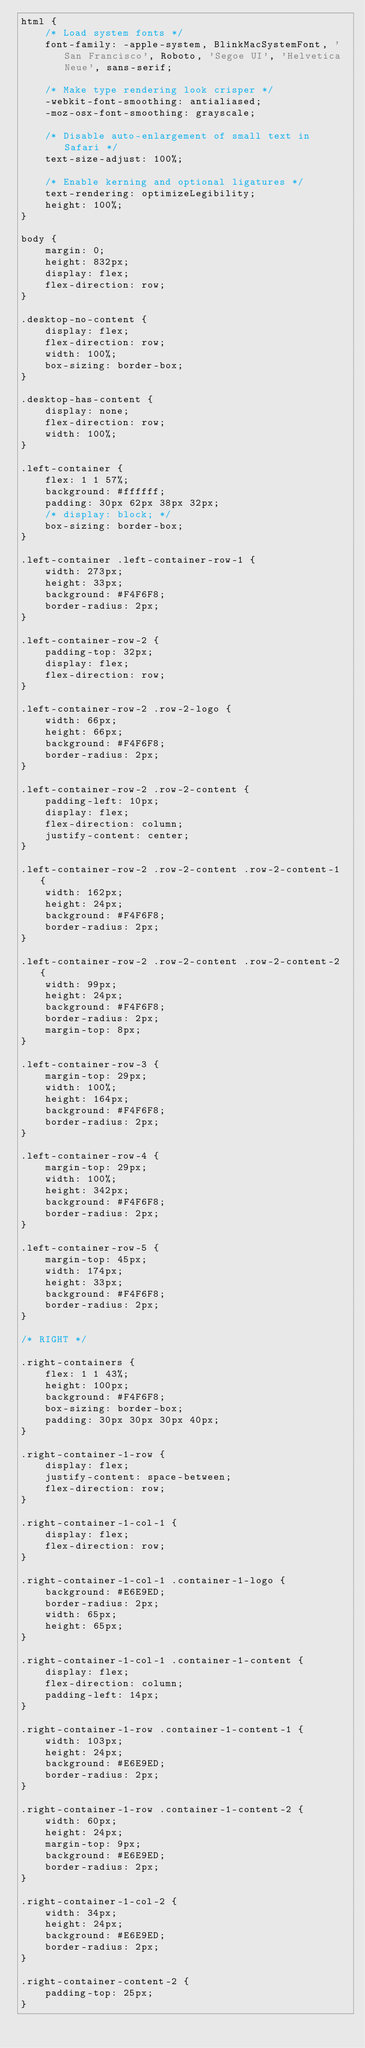Convert code to text. <code><loc_0><loc_0><loc_500><loc_500><_CSS_>html {
    /* Load system fonts */
    font-family: -apple-system, BlinkMacSystemFont, 'San Francisco', Roboto, 'Segoe UI', 'Helvetica Neue', sans-serif;
  
    /* Make type rendering look crisper */
    -webkit-font-smoothing: antialiased;
    -moz-osx-font-smoothing: grayscale;
  
    /* Disable auto-enlargement of small text in Safari */
    text-size-adjust: 100%;
  
    /* Enable kerning and optional ligatures */
    text-rendering: optimizeLegibility;
    height: 100%;
}

body {
    margin: 0;
    height: 832px;
    display: flex;
    flex-direction: row;
}

.desktop-no-content {
    display: flex;
    flex-direction: row;
    width: 100%;
    box-sizing: border-box;
}

.desktop-has-content {
    display: none;
    flex-direction: row;
    width: 100%;
}

.left-container {
    flex: 1 1 57%;
    background: #ffffff;
    padding: 30px 62px 38px 32px;
    /* display: block; */
    box-sizing: border-box;
}

.left-container .left-container-row-1 {
    width: 273px;
    height: 33px;
    background: #F4F6F8;
    border-radius: 2px;
}

.left-container-row-2 {
    padding-top: 32px;
    display: flex;
    flex-direction: row;
}

.left-container-row-2 .row-2-logo {
    width: 66px;
    height: 66px;
    background: #F4F6F8;
    border-radius: 2px;
}

.left-container-row-2 .row-2-content {
    padding-left: 10px;
    display: flex;
    flex-direction: column;
    justify-content: center;
}

.left-container-row-2 .row-2-content .row-2-content-1 {
    width: 162px;
    height: 24px;
    background: #F4F6F8;
    border-radius: 2px;
}

.left-container-row-2 .row-2-content .row-2-content-2 {
    width: 99px;
    height: 24px;
    background: #F4F6F8;
    border-radius: 2px;
    margin-top: 8px;
}

.left-container-row-3 {
    margin-top: 29px;
    width: 100%;
    height: 164px;
    background: #F4F6F8;
    border-radius: 2px;
}

.left-container-row-4 {
    margin-top: 29px;
    width: 100%;
    height: 342px;
    background: #F4F6F8;
    border-radius: 2px;
}

.left-container-row-5 {
    margin-top: 45px;
    width: 174px;
    height: 33px;
    background: #F4F6F8;
    border-radius: 2px;
}

/* RIGHT */

.right-containers {
    flex: 1 1 43%;
    height: 100px;
    background: #F4F6F8;
    box-sizing: border-box;
    padding: 30px 30px 30px 40px;
}

.right-container-1-row {
    display: flex;
    justify-content: space-between;
    flex-direction: row;
}

.right-container-1-col-1 {
    display: flex;
    flex-direction: row;
}

.right-container-1-col-1 .container-1-logo {
    background: #E6E9ED;
    border-radius: 2px;
    width: 65px;
    height: 65px;
}

.right-container-1-col-1 .container-1-content {
    display: flex;
    flex-direction: column;
    padding-left: 14px;
}

.right-container-1-row .container-1-content-1 {
    width: 103px;
    height: 24px;
    background: #E6E9ED;
    border-radius: 2px;
}

.right-container-1-row .container-1-content-2 {
    width: 60px;
    height: 24px;
    margin-top: 9px;
    background: #E6E9ED;
    border-radius: 2px;
}

.right-container-1-col-2 {
    width: 34px;
    height: 24px;
    background: #E6E9ED;
    border-radius: 2px;
}

.right-container-content-2 {
    padding-top: 25px;
}
</code> 